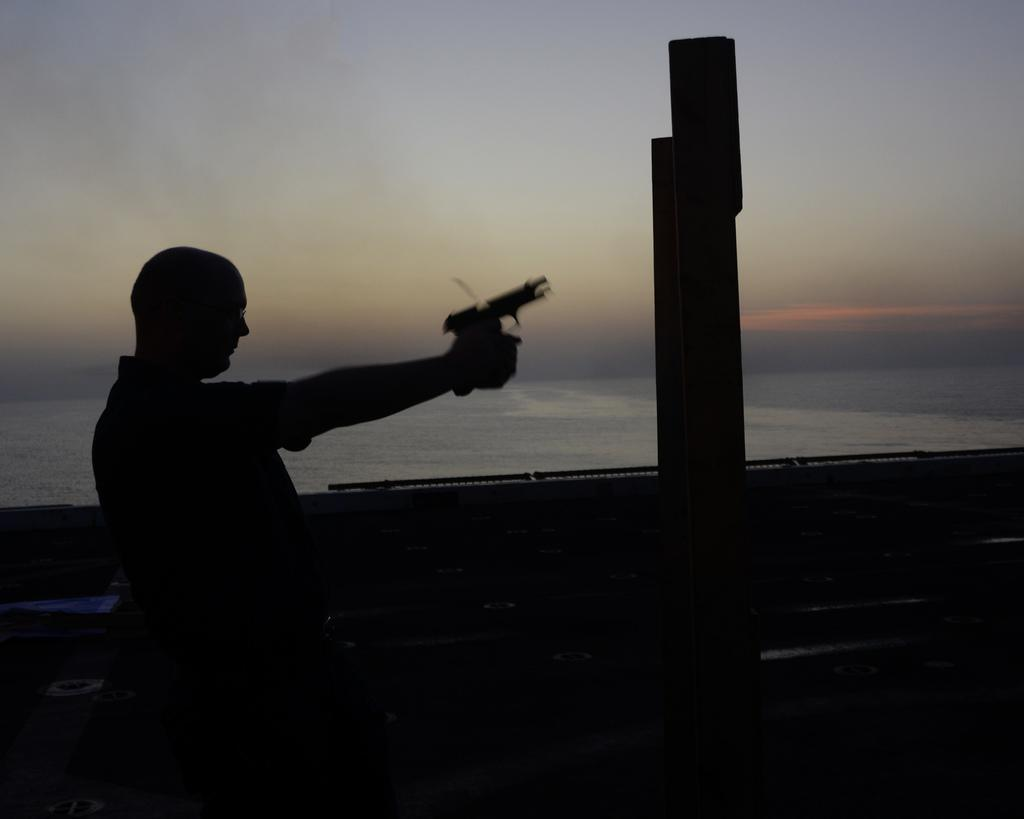What is the main subject of the image? There is a man in the image. What is the man holding in the image? The man is holding a gun. What is located beside the man in the image? There is a wall beside the man. What can be seen behind the wall in the image? There is a sea behind the wall. What type of sweater is the man wearing in the image? The image does not show the man wearing a sweater, so it cannot be determined from the image. 